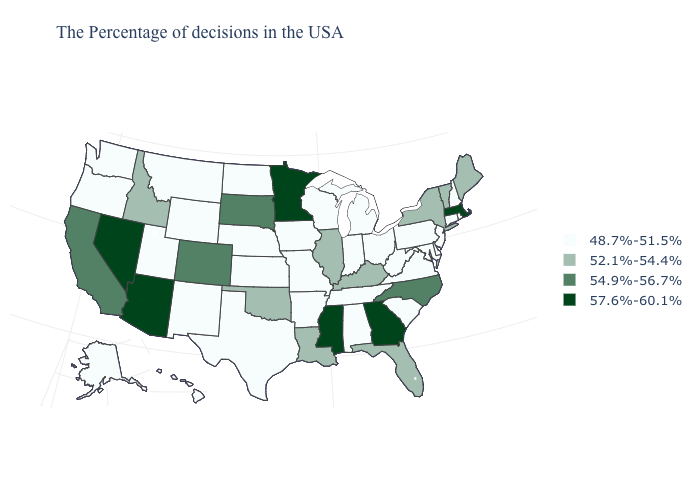Which states have the lowest value in the USA?
Keep it brief. Rhode Island, New Hampshire, Connecticut, New Jersey, Delaware, Maryland, Pennsylvania, Virginia, South Carolina, West Virginia, Ohio, Michigan, Indiana, Alabama, Tennessee, Wisconsin, Missouri, Arkansas, Iowa, Kansas, Nebraska, Texas, North Dakota, Wyoming, New Mexico, Utah, Montana, Washington, Oregon, Alaska, Hawaii. What is the value of Pennsylvania?
Concise answer only. 48.7%-51.5%. What is the value of California?
Write a very short answer. 54.9%-56.7%. What is the lowest value in states that border Arkansas?
Short answer required. 48.7%-51.5%. Name the states that have a value in the range 52.1%-54.4%?
Quick response, please. Maine, Vermont, New York, Florida, Kentucky, Illinois, Louisiana, Oklahoma, Idaho. What is the value of Arizona?
Concise answer only. 57.6%-60.1%. Name the states that have a value in the range 57.6%-60.1%?
Give a very brief answer. Massachusetts, Georgia, Mississippi, Minnesota, Arizona, Nevada. Among the states that border West Virginia , does Maryland have the highest value?
Quick response, please. No. Does Nebraska have a higher value than Virginia?
Be succinct. No. Does the map have missing data?
Be succinct. No. Which states hav the highest value in the West?
Concise answer only. Arizona, Nevada. What is the value of South Dakota?
Concise answer only. 54.9%-56.7%. What is the highest value in the South ?
Write a very short answer. 57.6%-60.1%. Name the states that have a value in the range 57.6%-60.1%?
Concise answer only. Massachusetts, Georgia, Mississippi, Minnesota, Arizona, Nevada. Does Arkansas have a lower value than Colorado?
Concise answer only. Yes. 